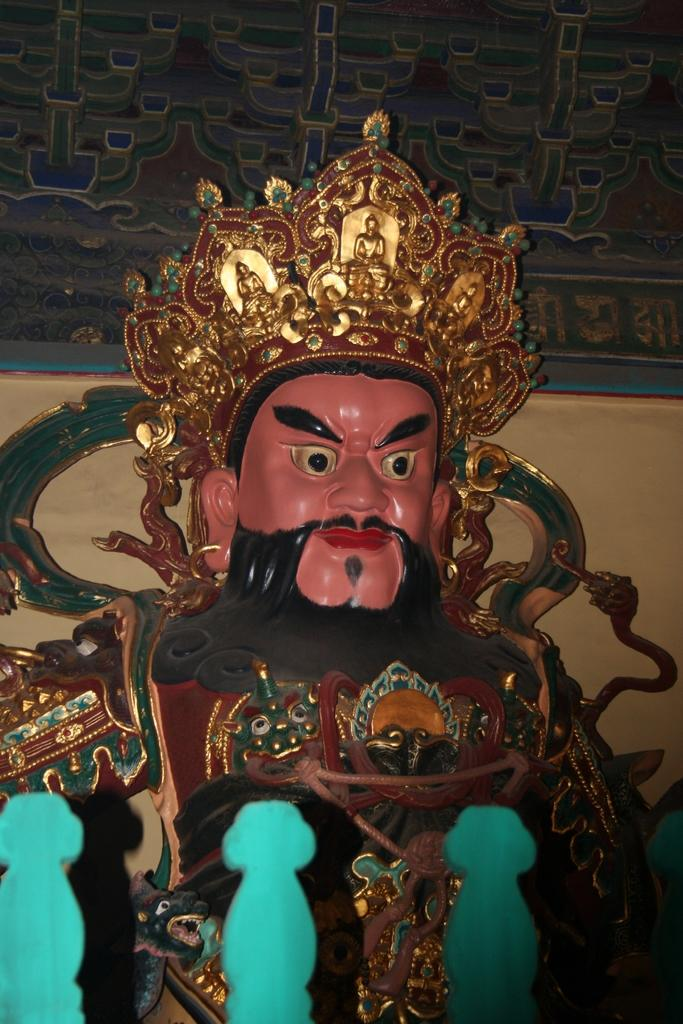What is the main subject of the image? There is an idol or statue of a man wearing a crown in the image. What can be seen at the bottom of the image? There are three objects in green color at the bottom of the image. What is visible in the background of the image? There is a wall visible in the background of the image. How many frogs are sitting on the statue's head in the image? There are no frogs present in the image; the statue is wearing a crown. What type of banana is being used as a prop in the image? There is no banana present in the image. 